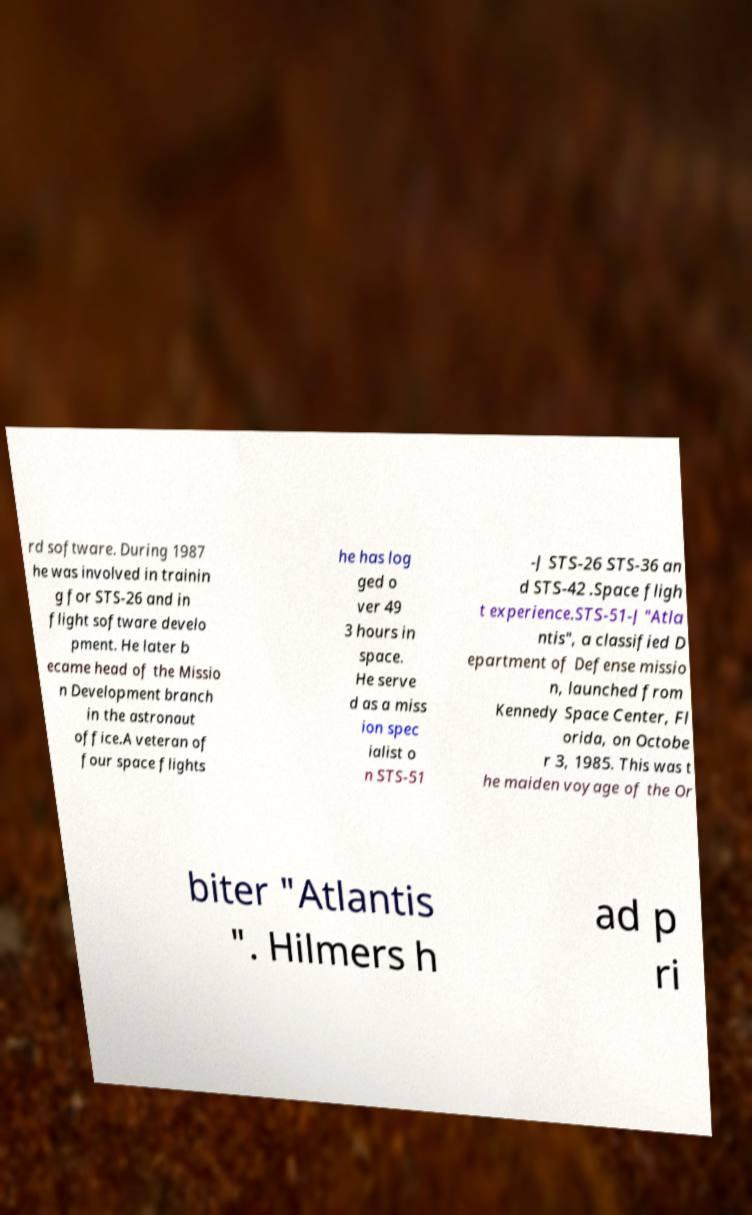There's text embedded in this image that I need extracted. Can you transcribe it verbatim? rd software. During 1987 he was involved in trainin g for STS-26 and in flight software develo pment. He later b ecame head of the Missio n Development branch in the astronaut office.A veteran of four space flights he has log ged o ver 49 3 hours in space. He serve d as a miss ion spec ialist o n STS-51 -J STS-26 STS-36 an d STS-42 .Space fligh t experience.STS-51-J "Atla ntis", a classified D epartment of Defense missio n, launched from Kennedy Space Center, Fl orida, on Octobe r 3, 1985. This was t he maiden voyage of the Or biter "Atlantis ". Hilmers h ad p ri 